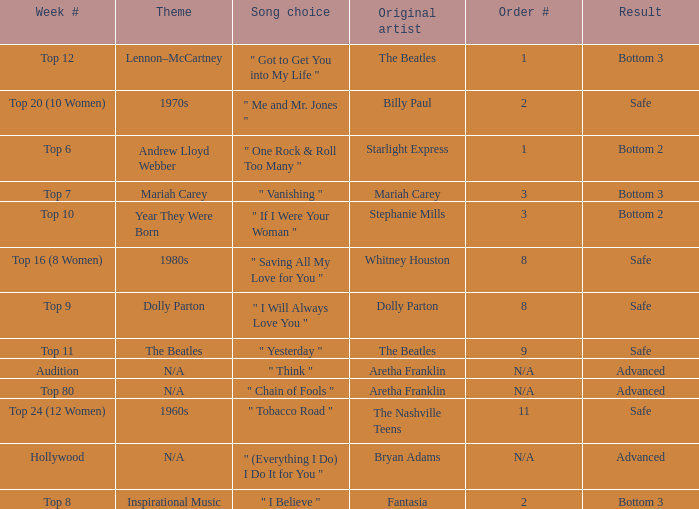Name the song choice when week number is hollywood " (Everything I Do) I Do It for You ". Give me the full table as a dictionary. {'header': ['Week #', 'Theme', 'Song choice', 'Original artist', 'Order #', 'Result'], 'rows': [['Top 12', 'Lennon–McCartney', '" Got to Get You into My Life "', 'The Beatles', '1', 'Bottom 3'], ['Top 20 (10 Women)', '1970s', '" Me and Mr. Jones "', 'Billy Paul', '2', 'Safe'], ['Top 6', 'Andrew Lloyd Webber', '" One Rock & Roll Too Many "', 'Starlight Express', '1', 'Bottom 2'], ['Top 7', 'Mariah Carey', '" Vanishing "', 'Mariah Carey', '3', 'Bottom 3'], ['Top 10', 'Year They Were Born', '" If I Were Your Woman "', 'Stephanie Mills', '3', 'Bottom 2'], ['Top 16 (8 Women)', '1980s', '" Saving All My Love for You "', 'Whitney Houston', '8', 'Safe'], ['Top 9', 'Dolly Parton', '" I Will Always Love You "', 'Dolly Parton', '8', 'Safe'], ['Top 11', 'The Beatles', '" Yesterday "', 'The Beatles', '9', 'Safe'], ['Audition', 'N/A', '" Think "', 'Aretha Franklin', 'N/A', 'Advanced'], ['Top 80', 'N/A', '" Chain of Fools "', 'Aretha Franklin', 'N/A', 'Advanced'], ['Top 24 (12 Women)', '1960s', '" Tobacco Road "', 'The Nashville Teens', '11', 'Safe'], ['Hollywood', 'N/A', '" (Everything I Do) I Do It for You "', 'Bryan Adams', 'N/A', 'Advanced'], ['Top 8', 'Inspirational Music', '" I Believe "', 'Fantasia', '2', 'Bottom 3']]} 